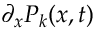<formula> <loc_0><loc_0><loc_500><loc_500>\partial _ { x } P _ { k } ( x , t )</formula> 